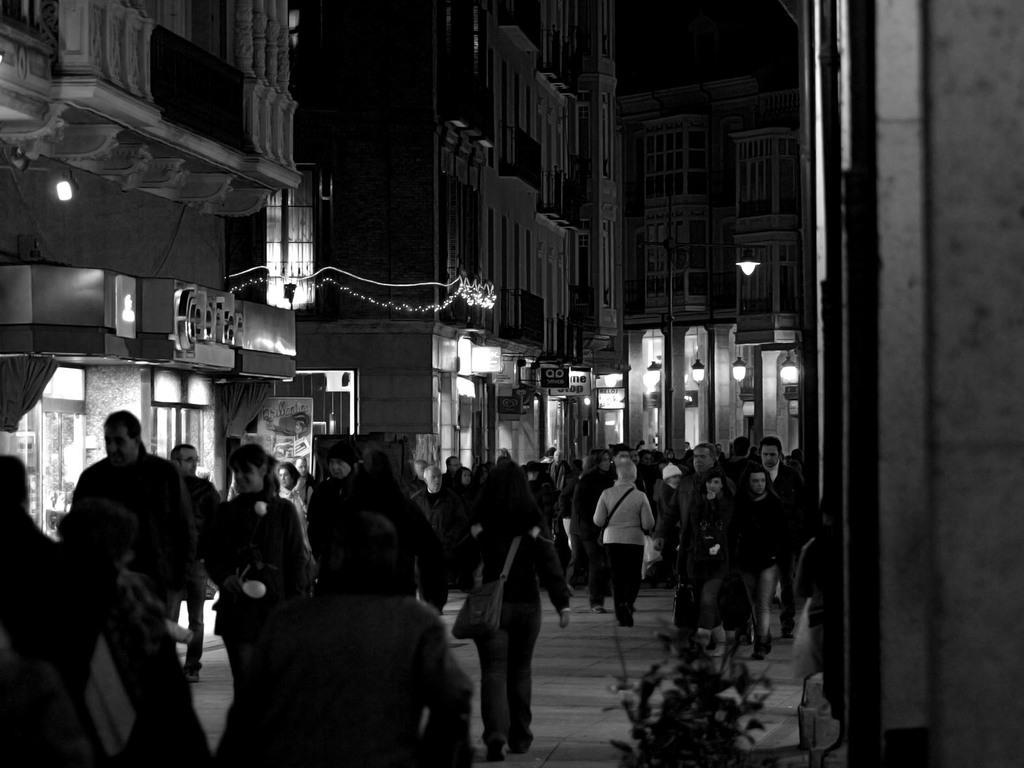Could you give a brief overview of what you see in this image? In this image I can see the group of people walking. These people are wearing the bags. To the side of the people I can see the buildings, light poles and some boards. 